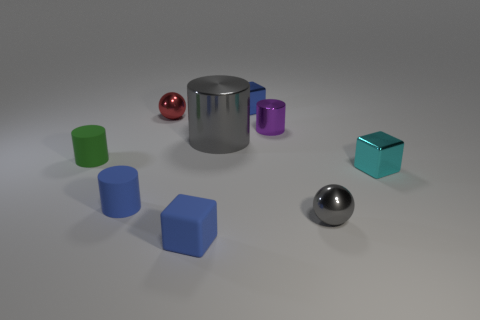Subtract all tiny rubber blocks. How many blocks are left? 2 Add 1 green cylinders. How many objects exist? 10 Subtract all red cylinders. How many blue blocks are left? 2 Subtract all gray cylinders. How many cylinders are left? 3 Subtract 1 blocks. How many blocks are left? 2 Subtract all blocks. How many objects are left? 6 Subtract all blue spheres. Subtract all blue cubes. How many spheres are left? 2 Subtract all big brown metal objects. Subtract all small gray balls. How many objects are left? 8 Add 7 tiny cyan metallic objects. How many tiny cyan metallic objects are left? 8 Add 6 gray spheres. How many gray spheres exist? 7 